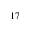<formula> <loc_0><loc_0><loc_500><loc_500>_ { 1 7 }</formula> 